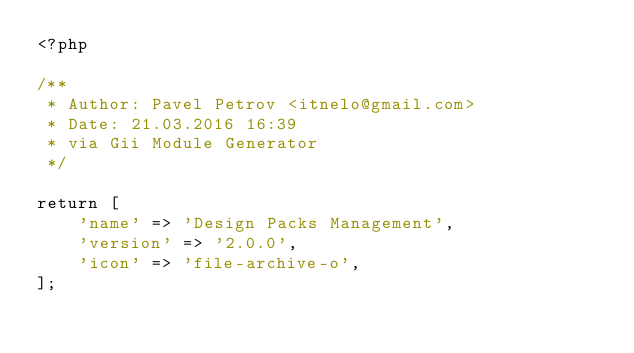Convert code to text. <code><loc_0><loc_0><loc_500><loc_500><_PHP_><?php

/**
 * Author: Pavel Petrov <itnelo@gmail.com>
 * Date: 21.03.2016 16:39
 * via Gii Module Generator
 */

return [
    'name' => 'Design Packs Management',
    'version' => '2.0.0',
    'icon' => 'file-archive-o',
];</code> 